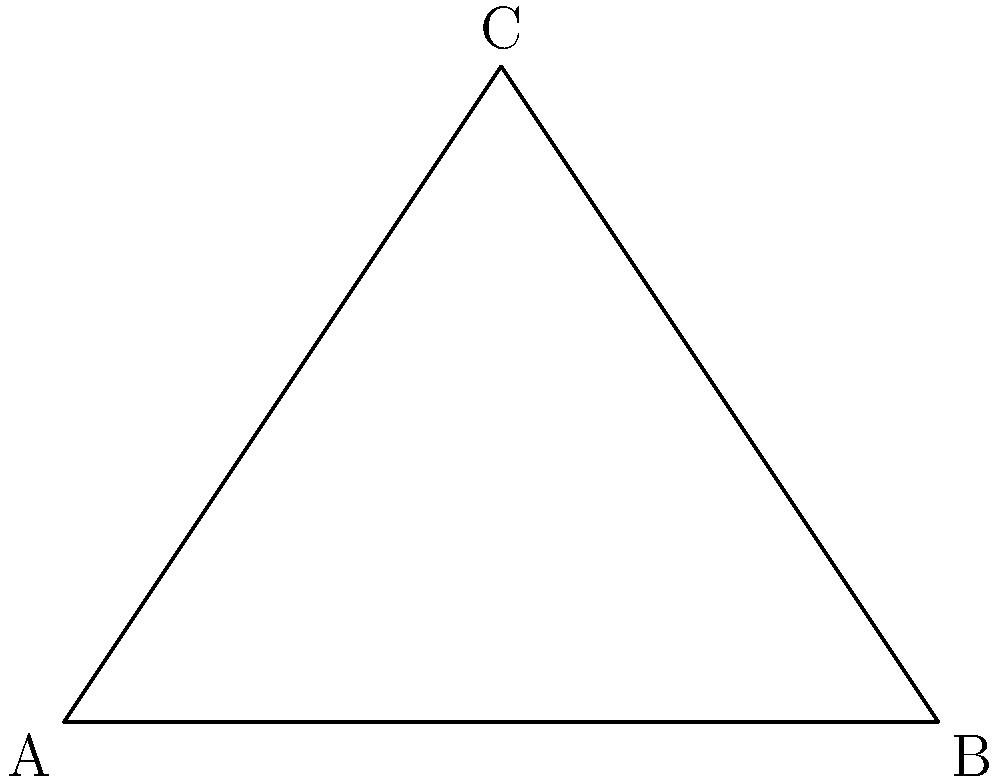In a grip-fighting technique used by British judoka Ashley McKenzie, his arm forms a triangle with his opponent's body. If one angle of this triangle is a right angle and another is 30°, what is the measure of the third angle (x°)? Let's approach this step-by-step:

1) In any triangle, the sum of all interior angles is always 180°.

2) We're given that one angle is a right angle (90°) and another is 30°.

3) Let's call the third angle x°.

4) We can set up an equation:
   
   $90° + 30° + x° = 180°$

5) Simplify:
   
   $120° + x° = 180°$

6) Subtract 120° from both sides:
   
   $x° = 180° - 120°$

7) Solve for x:
   
   $x° = 60°$

Therefore, the measure of the third angle in Ashley McKenzie's grip-fighting triangle is 60°.
Answer: 60° 